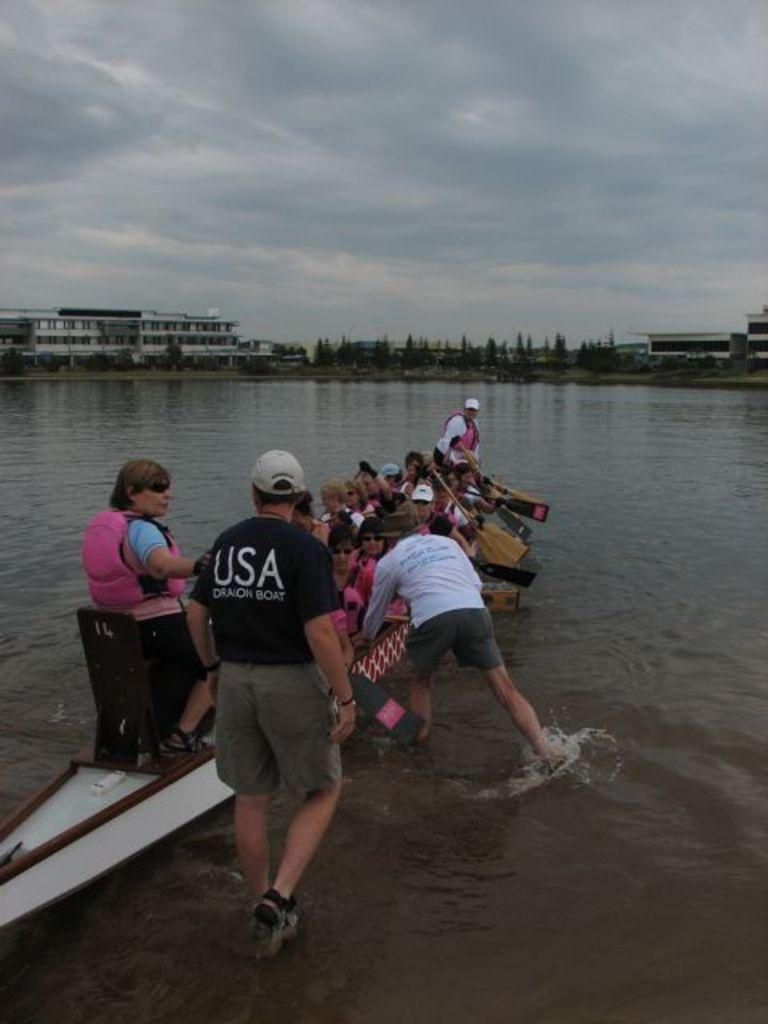What are the people doing in the image? The people are on a boat and in motion. What are the people using to propel the boat? There are paddles visible in the image, which are likely being used by the people to move the boat. What can be seen in the background of the image? There are trees, buildings, and the sky visible in the background. What type of environment is the boat in? The boat is in a watery environment, as indicated by the presence of water in the image. What is the purpose of the test being conducted on the boat in the image? There is no indication of a test being conducted in the image; the people are simply using paddles to move the boat. Can you tell me how many jokes are being told by the people on the boat in the image? There is no indication of humor or jokes being told in the image; the people are focused on paddling the boat. 